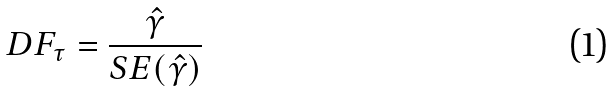<formula> <loc_0><loc_0><loc_500><loc_500>D F _ { \tau } = \frac { \hat { \gamma } } { S E ( \hat { \gamma } ) }</formula> 